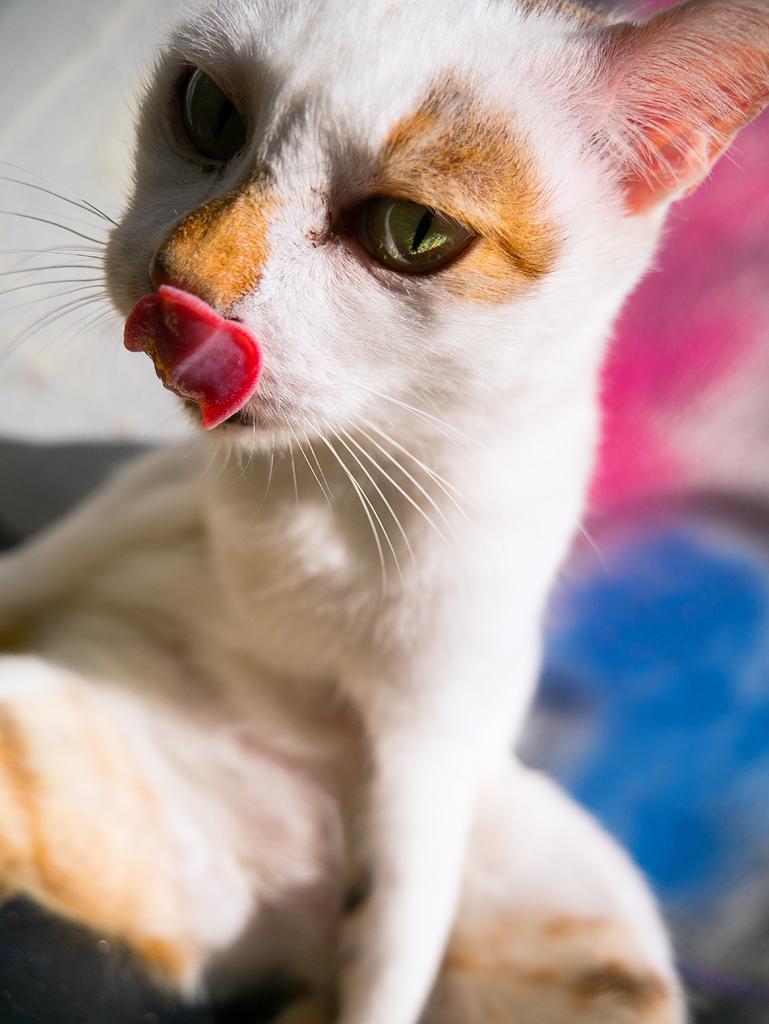Could you give a brief overview of what you see in this image? Here we can see a cat. In the background the image is blur but we can see some objects. 